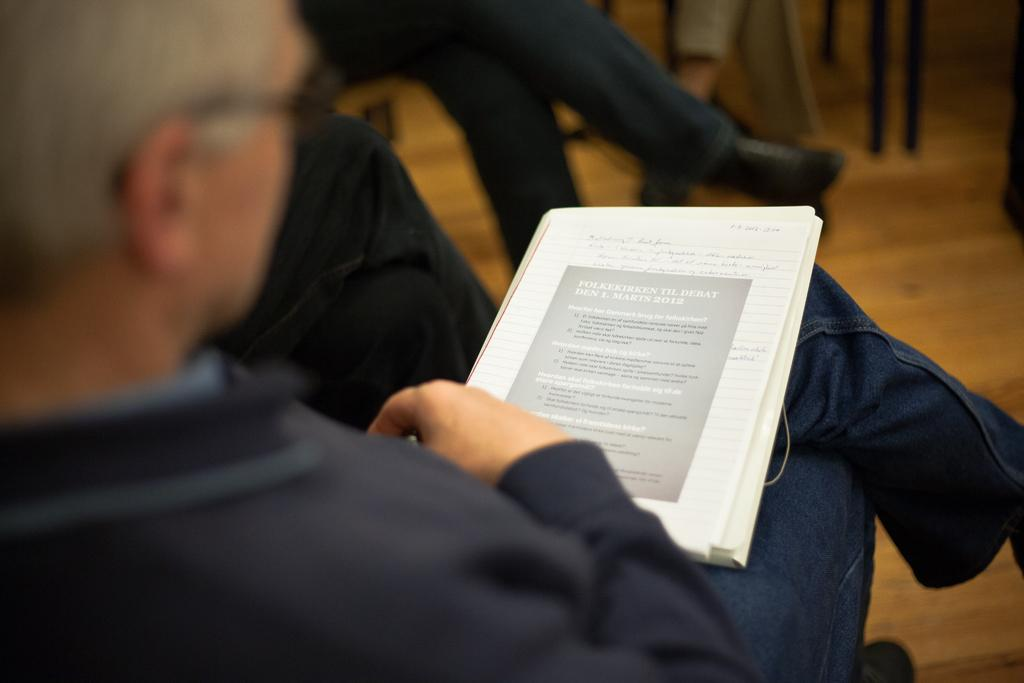What is the person in the image doing? There is a person sitting on a chair in the image. What is the person holding or interacting with while sitting on the chair? The person has a book on their lap. Are there any other people in the image? Yes, there are other people sitting on chairs in the image. What is the person thinking about while reading the book in the image? The image does not provide information about the person's thoughts, so we cannot determine what they are thinking about. 